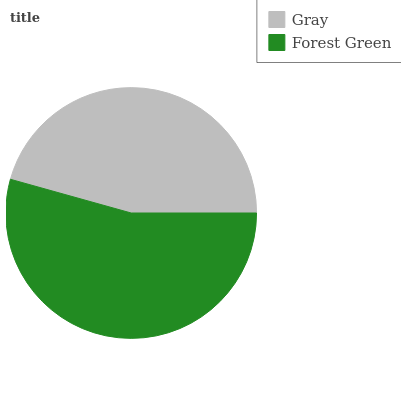Is Gray the minimum?
Answer yes or no. Yes. Is Forest Green the maximum?
Answer yes or no. Yes. Is Forest Green the minimum?
Answer yes or no. No. Is Forest Green greater than Gray?
Answer yes or no. Yes. Is Gray less than Forest Green?
Answer yes or no. Yes. Is Gray greater than Forest Green?
Answer yes or no. No. Is Forest Green less than Gray?
Answer yes or no. No. Is Forest Green the high median?
Answer yes or no. Yes. Is Gray the low median?
Answer yes or no. Yes. Is Gray the high median?
Answer yes or no. No. Is Forest Green the low median?
Answer yes or no. No. 